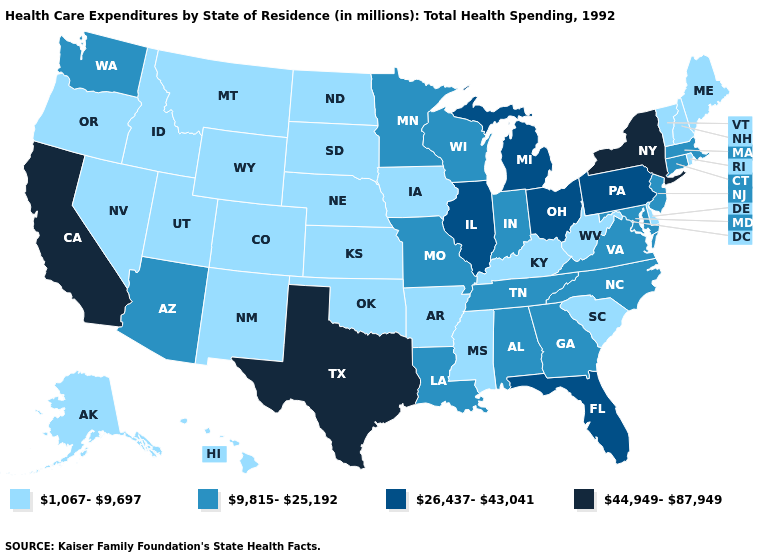What is the value of Wisconsin?
Give a very brief answer. 9,815-25,192. Which states hav the highest value in the South?
Concise answer only. Texas. Among the states that border Arkansas , does Oklahoma have the lowest value?
Quick response, please. Yes. Does California have the highest value in the USA?
Quick response, please. Yes. Which states have the highest value in the USA?
Be succinct. California, New York, Texas. What is the value of Wyoming?
Concise answer only. 1,067-9,697. Name the states that have a value in the range 26,437-43,041?
Keep it brief. Florida, Illinois, Michigan, Ohio, Pennsylvania. Name the states that have a value in the range 1,067-9,697?
Keep it brief. Alaska, Arkansas, Colorado, Delaware, Hawaii, Idaho, Iowa, Kansas, Kentucky, Maine, Mississippi, Montana, Nebraska, Nevada, New Hampshire, New Mexico, North Dakota, Oklahoma, Oregon, Rhode Island, South Carolina, South Dakota, Utah, Vermont, West Virginia, Wyoming. What is the lowest value in the USA?
Quick response, please. 1,067-9,697. What is the highest value in the USA?
Be succinct. 44,949-87,949. How many symbols are there in the legend?
Short answer required. 4. Does Kentucky have the same value as Colorado?
Give a very brief answer. Yes. Does Pennsylvania have a higher value than Illinois?
Give a very brief answer. No. What is the value of Kentucky?
Quick response, please. 1,067-9,697. Name the states that have a value in the range 9,815-25,192?
Keep it brief. Alabama, Arizona, Connecticut, Georgia, Indiana, Louisiana, Maryland, Massachusetts, Minnesota, Missouri, New Jersey, North Carolina, Tennessee, Virginia, Washington, Wisconsin. 